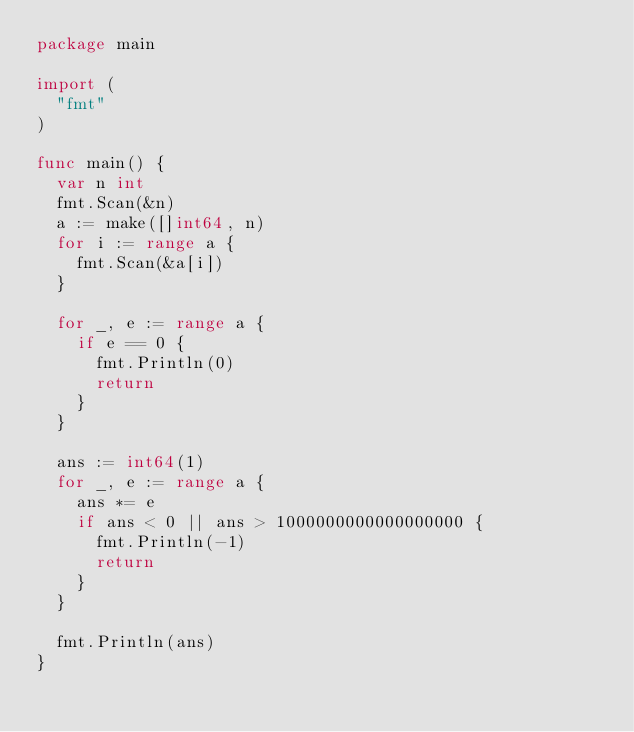<code> <loc_0><loc_0><loc_500><loc_500><_Go_>package main

import (
	"fmt"
)

func main() {
	var n int
	fmt.Scan(&n)
	a := make([]int64, n)
	for i := range a {
		fmt.Scan(&a[i])
	}

	for _, e := range a {
		if e == 0 {
			fmt.Println(0)
			return
		}
	}

	ans := int64(1)
	for _, e := range a {
		ans *= e
		if ans < 0 || ans > 1000000000000000000 {
			fmt.Println(-1)
			return
		}
	}

	fmt.Println(ans)
}
</code> 